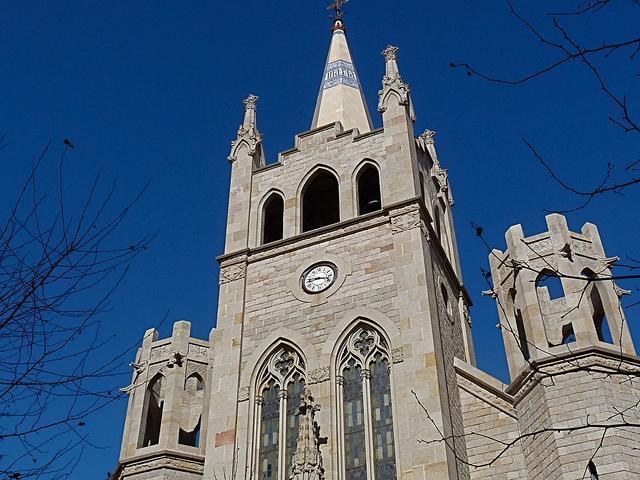How many clocks are on the building?
Give a very brief answer. 1. How many of the motorcycles are blue?
Give a very brief answer. 0. 